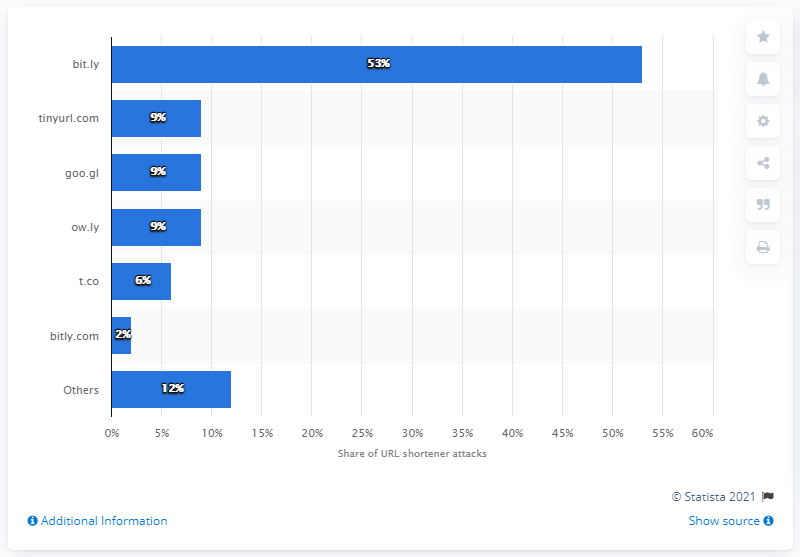Point out several critical features in this image. According to the analysis, ow.ly was ranked second with a nine percent share of URL shortener phishing attacks. 